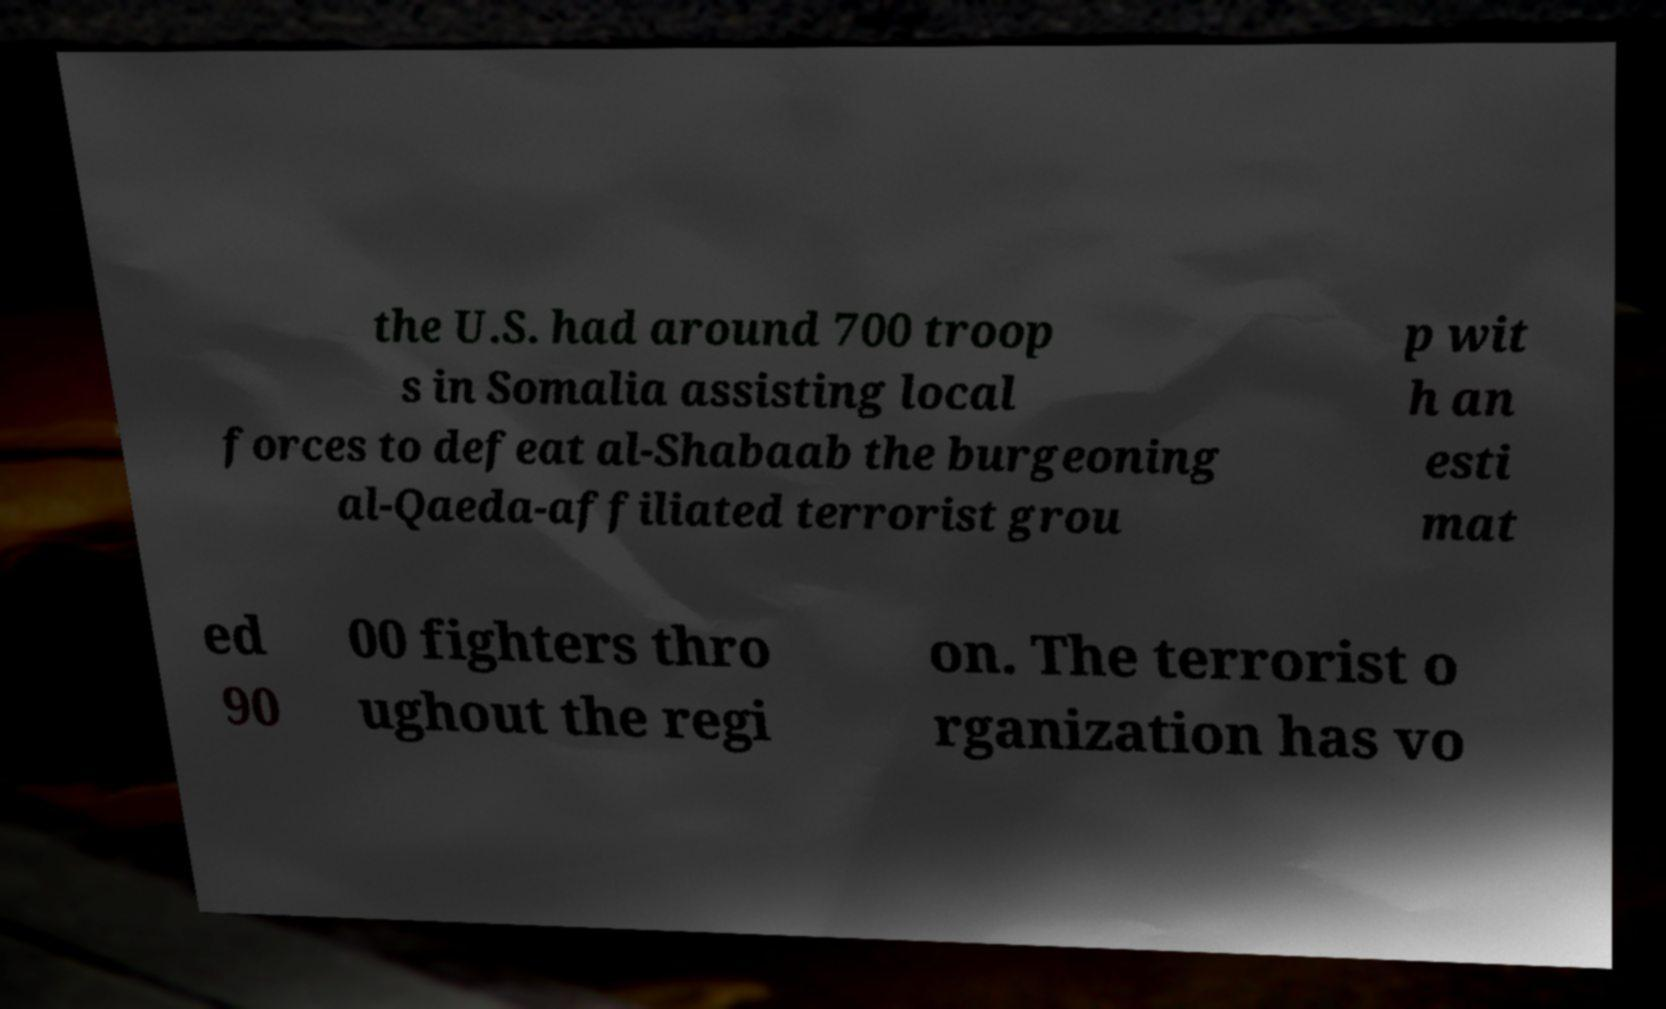Can you accurately transcribe the text from the provided image for me? the U.S. had around 700 troop s in Somalia assisting local forces to defeat al-Shabaab the burgeoning al-Qaeda-affiliated terrorist grou p wit h an esti mat ed 90 00 fighters thro ughout the regi on. The terrorist o rganization has vo 